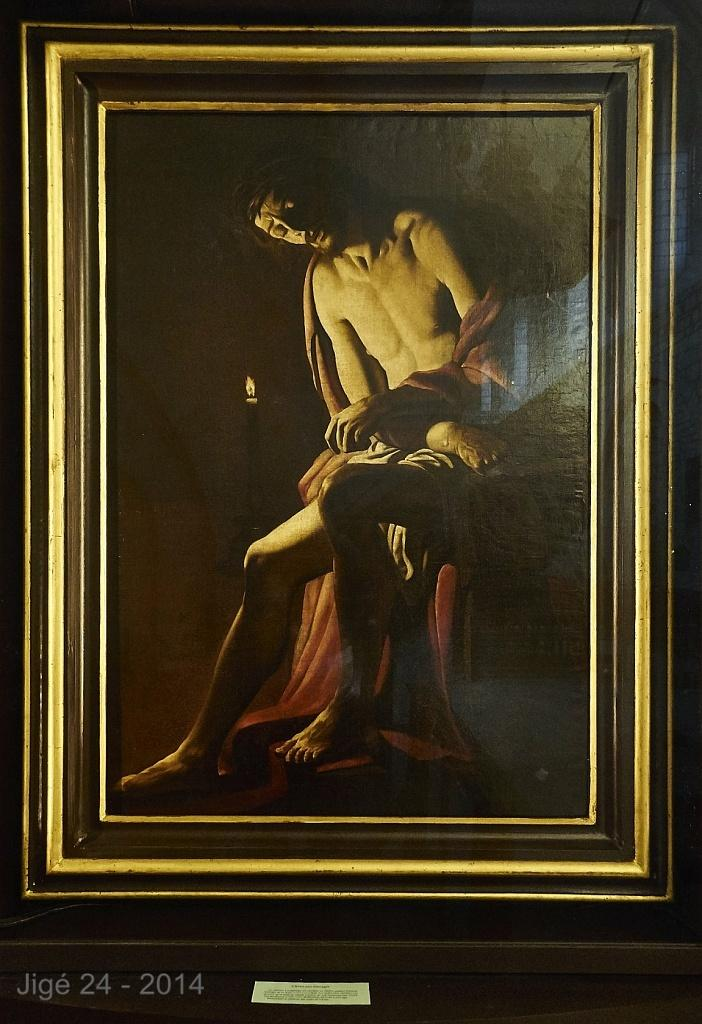<image>
Offer a succinct explanation of the picture presented. a poster of a man sitting on Jige 24 - 2014 